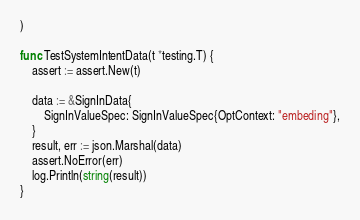Convert code to text. <code><loc_0><loc_0><loc_500><loc_500><_Go_>)

func TestSystemIntentData(t *testing.T) {
	assert := assert.New(t)

	data := &SignInData{
		SignInValueSpec: SignInValueSpec{OptContext: "embeding"},
	}
	result, err := json.Marshal(data)
	assert.NoError(err)
	log.Println(string(result))
}
</code> 